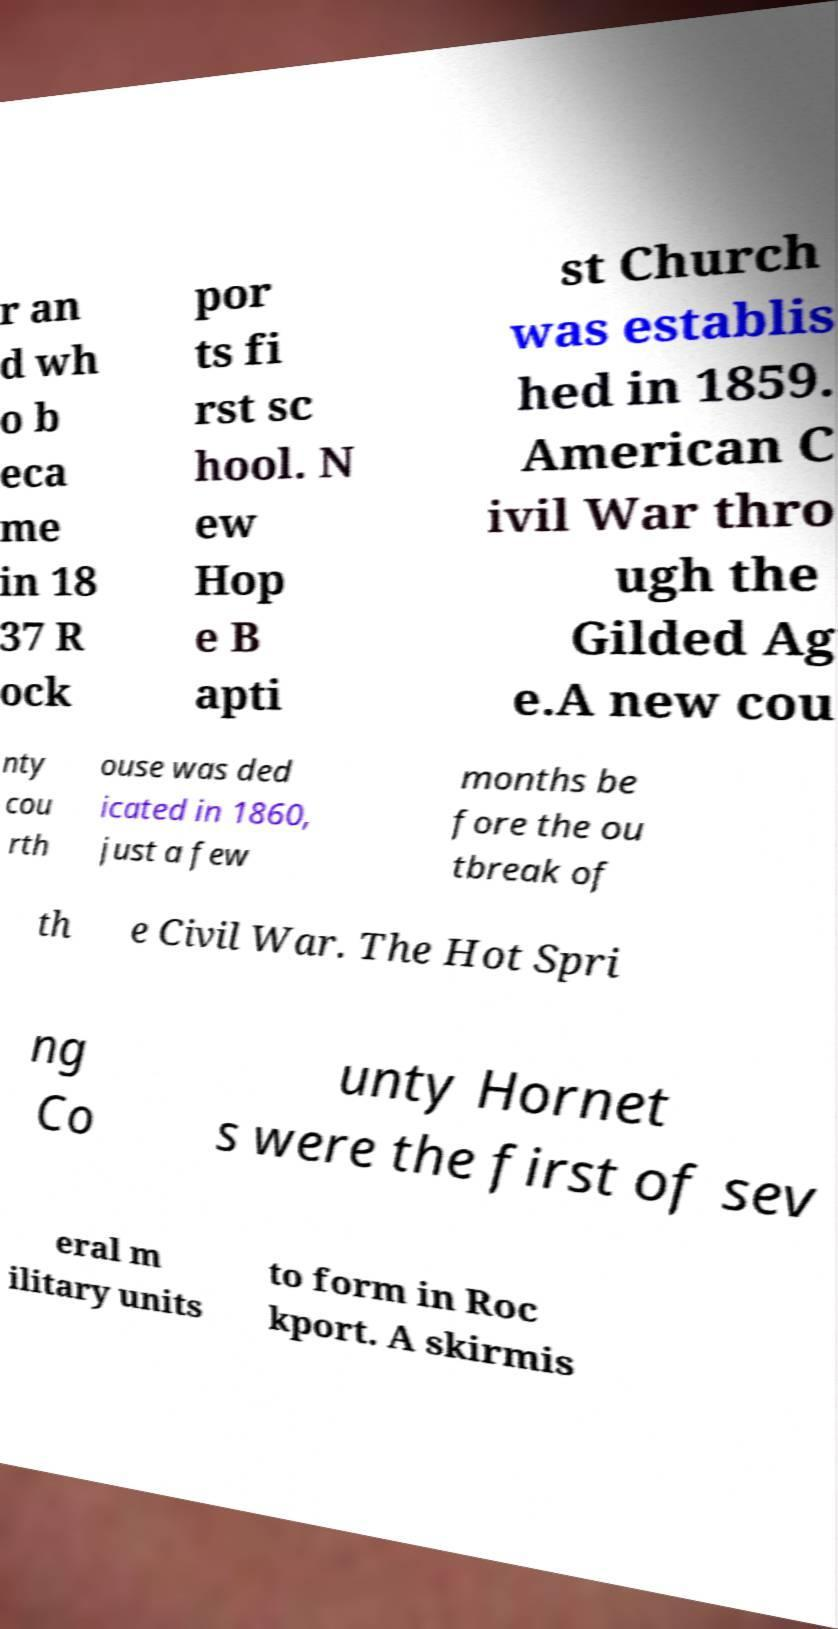For documentation purposes, I need the text within this image transcribed. Could you provide that? r an d wh o b eca me in 18 37 R ock por ts fi rst sc hool. N ew Hop e B apti st Church was establis hed in 1859. American C ivil War thro ugh the Gilded Ag e.A new cou nty cou rth ouse was ded icated in 1860, just a few months be fore the ou tbreak of th e Civil War. The Hot Spri ng Co unty Hornet s were the first of sev eral m ilitary units to form in Roc kport. A skirmis 